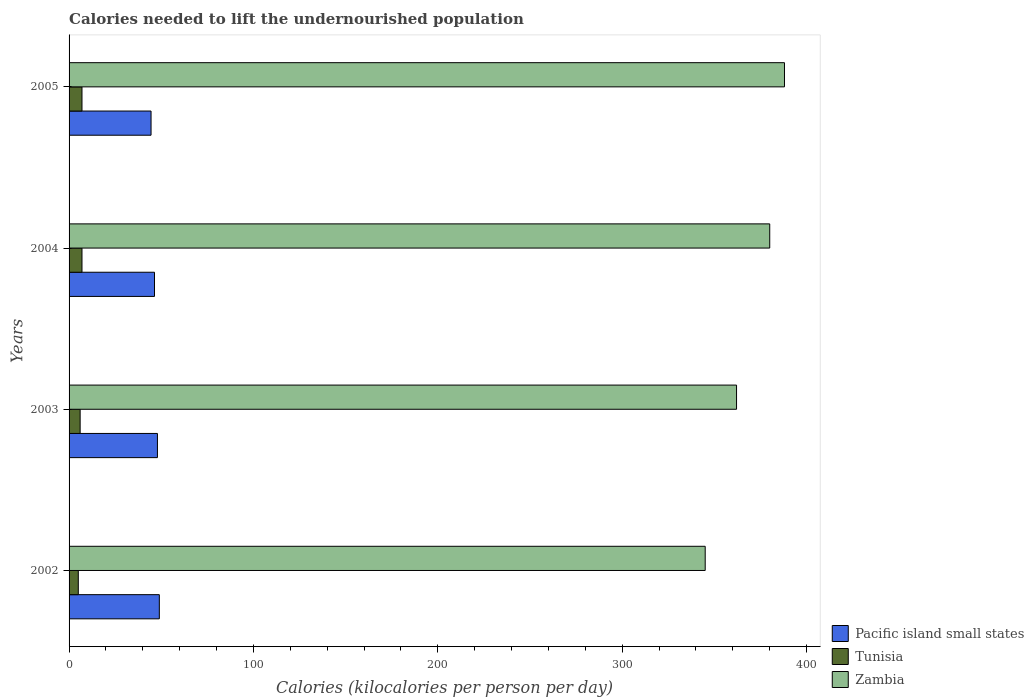How many different coloured bars are there?
Your answer should be very brief. 3. How many groups of bars are there?
Provide a succinct answer. 4. How many bars are there on the 4th tick from the top?
Offer a terse response. 3. How many bars are there on the 2nd tick from the bottom?
Your answer should be very brief. 3. What is the total calories needed to lift the undernourished population in Zambia in 2003?
Offer a very short reply. 362. Across all years, what is the maximum total calories needed to lift the undernourished population in Zambia?
Give a very brief answer. 388. Across all years, what is the minimum total calories needed to lift the undernourished population in Pacific island small states?
Provide a succinct answer. 44.46. What is the total total calories needed to lift the undernourished population in Pacific island small states in the graph?
Keep it short and to the point. 187.66. What is the difference between the total calories needed to lift the undernourished population in Tunisia in 2002 and that in 2005?
Your answer should be very brief. -2. What is the difference between the total calories needed to lift the undernourished population in Tunisia in 2005 and the total calories needed to lift the undernourished population in Pacific island small states in 2003?
Offer a very short reply. -40.92. What is the average total calories needed to lift the undernourished population in Tunisia per year?
Provide a succinct answer. 6.25. In the year 2002, what is the difference between the total calories needed to lift the undernourished population in Pacific island small states and total calories needed to lift the undernourished population in Zambia?
Provide a short and direct response. -296.05. What is the ratio of the total calories needed to lift the undernourished population in Zambia in 2002 to that in 2004?
Keep it short and to the point. 0.91. Is the total calories needed to lift the undernourished population in Zambia in 2002 less than that in 2004?
Provide a short and direct response. Yes. What is the difference between the highest and the lowest total calories needed to lift the undernourished population in Zambia?
Your answer should be compact. 43. Is the sum of the total calories needed to lift the undernourished population in Pacific island small states in 2003 and 2005 greater than the maximum total calories needed to lift the undernourished population in Zambia across all years?
Keep it short and to the point. No. What does the 2nd bar from the top in 2003 represents?
Keep it short and to the point. Tunisia. What does the 1st bar from the bottom in 2003 represents?
Give a very brief answer. Pacific island small states. Is it the case that in every year, the sum of the total calories needed to lift the undernourished population in Tunisia and total calories needed to lift the undernourished population in Zambia is greater than the total calories needed to lift the undernourished population in Pacific island small states?
Give a very brief answer. Yes. Are all the bars in the graph horizontal?
Offer a terse response. Yes. How many years are there in the graph?
Keep it short and to the point. 4. What is the difference between two consecutive major ticks on the X-axis?
Ensure brevity in your answer.  100. Are the values on the major ticks of X-axis written in scientific E-notation?
Your response must be concise. No. Does the graph contain any zero values?
Provide a succinct answer. No. How many legend labels are there?
Offer a terse response. 3. How are the legend labels stacked?
Your answer should be very brief. Vertical. What is the title of the graph?
Ensure brevity in your answer.  Calories needed to lift the undernourished population. What is the label or title of the X-axis?
Ensure brevity in your answer.  Calories (kilocalories per person per day). What is the Calories (kilocalories per person per day) of Pacific island small states in 2002?
Offer a very short reply. 48.95. What is the Calories (kilocalories per person per day) of Tunisia in 2002?
Offer a very short reply. 5. What is the Calories (kilocalories per person per day) in Zambia in 2002?
Offer a terse response. 345. What is the Calories (kilocalories per person per day) of Pacific island small states in 2003?
Your answer should be compact. 47.92. What is the Calories (kilocalories per person per day) of Tunisia in 2003?
Your answer should be compact. 6. What is the Calories (kilocalories per person per day) in Zambia in 2003?
Keep it short and to the point. 362. What is the Calories (kilocalories per person per day) in Pacific island small states in 2004?
Your answer should be compact. 46.33. What is the Calories (kilocalories per person per day) in Tunisia in 2004?
Offer a very short reply. 7. What is the Calories (kilocalories per person per day) of Zambia in 2004?
Offer a very short reply. 380. What is the Calories (kilocalories per person per day) in Pacific island small states in 2005?
Make the answer very short. 44.46. What is the Calories (kilocalories per person per day) of Zambia in 2005?
Keep it short and to the point. 388. Across all years, what is the maximum Calories (kilocalories per person per day) in Pacific island small states?
Your answer should be compact. 48.95. Across all years, what is the maximum Calories (kilocalories per person per day) of Zambia?
Keep it short and to the point. 388. Across all years, what is the minimum Calories (kilocalories per person per day) of Pacific island small states?
Make the answer very short. 44.46. Across all years, what is the minimum Calories (kilocalories per person per day) of Tunisia?
Give a very brief answer. 5. Across all years, what is the minimum Calories (kilocalories per person per day) in Zambia?
Make the answer very short. 345. What is the total Calories (kilocalories per person per day) in Pacific island small states in the graph?
Your answer should be very brief. 187.66. What is the total Calories (kilocalories per person per day) of Zambia in the graph?
Your response must be concise. 1475. What is the difference between the Calories (kilocalories per person per day) in Pacific island small states in 2002 and that in 2003?
Your answer should be compact. 1.03. What is the difference between the Calories (kilocalories per person per day) in Tunisia in 2002 and that in 2003?
Offer a terse response. -1. What is the difference between the Calories (kilocalories per person per day) in Pacific island small states in 2002 and that in 2004?
Ensure brevity in your answer.  2.62. What is the difference between the Calories (kilocalories per person per day) in Tunisia in 2002 and that in 2004?
Your answer should be compact. -2. What is the difference between the Calories (kilocalories per person per day) of Zambia in 2002 and that in 2004?
Provide a short and direct response. -35. What is the difference between the Calories (kilocalories per person per day) of Pacific island small states in 2002 and that in 2005?
Provide a succinct answer. 4.49. What is the difference between the Calories (kilocalories per person per day) of Zambia in 2002 and that in 2005?
Keep it short and to the point. -43. What is the difference between the Calories (kilocalories per person per day) of Pacific island small states in 2003 and that in 2004?
Provide a short and direct response. 1.59. What is the difference between the Calories (kilocalories per person per day) in Tunisia in 2003 and that in 2004?
Provide a succinct answer. -1. What is the difference between the Calories (kilocalories per person per day) of Pacific island small states in 2003 and that in 2005?
Offer a terse response. 3.47. What is the difference between the Calories (kilocalories per person per day) of Tunisia in 2003 and that in 2005?
Make the answer very short. -1. What is the difference between the Calories (kilocalories per person per day) in Zambia in 2003 and that in 2005?
Your answer should be very brief. -26. What is the difference between the Calories (kilocalories per person per day) in Pacific island small states in 2004 and that in 2005?
Keep it short and to the point. 1.87. What is the difference between the Calories (kilocalories per person per day) of Zambia in 2004 and that in 2005?
Provide a short and direct response. -8. What is the difference between the Calories (kilocalories per person per day) in Pacific island small states in 2002 and the Calories (kilocalories per person per day) in Tunisia in 2003?
Provide a short and direct response. 42.95. What is the difference between the Calories (kilocalories per person per day) in Pacific island small states in 2002 and the Calories (kilocalories per person per day) in Zambia in 2003?
Offer a terse response. -313.05. What is the difference between the Calories (kilocalories per person per day) in Tunisia in 2002 and the Calories (kilocalories per person per day) in Zambia in 2003?
Your answer should be compact. -357. What is the difference between the Calories (kilocalories per person per day) of Pacific island small states in 2002 and the Calories (kilocalories per person per day) of Tunisia in 2004?
Your answer should be compact. 41.95. What is the difference between the Calories (kilocalories per person per day) of Pacific island small states in 2002 and the Calories (kilocalories per person per day) of Zambia in 2004?
Provide a succinct answer. -331.05. What is the difference between the Calories (kilocalories per person per day) in Tunisia in 2002 and the Calories (kilocalories per person per day) in Zambia in 2004?
Your response must be concise. -375. What is the difference between the Calories (kilocalories per person per day) of Pacific island small states in 2002 and the Calories (kilocalories per person per day) of Tunisia in 2005?
Your answer should be compact. 41.95. What is the difference between the Calories (kilocalories per person per day) of Pacific island small states in 2002 and the Calories (kilocalories per person per day) of Zambia in 2005?
Ensure brevity in your answer.  -339.05. What is the difference between the Calories (kilocalories per person per day) of Tunisia in 2002 and the Calories (kilocalories per person per day) of Zambia in 2005?
Your answer should be very brief. -383. What is the difference between the Calories (kilocalories per person per day) of Pacific island small states in 2003 and the Calories (kilocalories per person per day) of Tunisia in 2004?
Keep it short and to the point. 40.92. What is the difference between the Calories (kilocalories per person per day) of Pacific island small states in 2003 and the Calories (kilocalories per person per day) of Zambia in 2004?
Make the answer very short. -332.08. What is the difference between the Calories (kilocalories per person per day) in Tunisia in 2003 and the Calories (kilocalories per person per day) in Zambia in 2004?
Provide a succinct answer. -374. What is the difference between the Calories (kilocalories per person per day) in Pacific island small states in 2003 and the Calories (kilocalories per person per day) in Tunisia in 2005?
Provide a short and direct response. 40.92. What is the difference between the Calories (kilocalories per person per day) in Pacific island small states in 2003 and the Calories (kilocalories per person per day) in Zambia in 2005?
Provide a short and direct response. -340.08. What is the difference between the Calories (kilocalories per person per day) of Tunisia in 2003 and the Calories (kilocalories per person per day) of Zambia in 2005?
Your answer should be very brief. -382. What is the difference between the Calories (kilocalories per person per day) in Pacific island small states in 2004 and the Calories (kilocalories per person per day) in Tunisia in 2005?
Keep it short and to the point. 39.33. What is the difference between the Calories (kilocalories per person per day) of Pacific island small states in 2004 and the Calories (kilocalories per person per day) of Zambia in 2005?
Give a very brief answer. -341.67. What is the difference between the Calories (kilocalories per person per day) in Tunisia in 2004 and the Calories (kilocalories per person per day) in Zambia in 2005?
Provide a short and direct response. -381. What is the average Calories (kilocalories per person per day) of Pacific island small states per year?
Your response must be concise. 46.92. What is the average Calories (kilocalories per person per day) of Tunisia per year?
Offer a terse response. 6.25. What is the average Calories (kilocalories per person per day) in Zambia per year?
Give a very brief answer. 368.75. In the year 2002, what is the difference between the Calories (kilocalories per person per day) in Pacific island small states and Calories (kilocalories per person per day) in Tunisia?
Provide a short and direct response. 43.95. In the year 2002, what is the difference between the Calories (kilocalories per person per day) of Pacific island small states and Calories (kilocalories per person per day) of Zambia?
Provide a succinct answer. -296.05. In the year 2002, what is the difference between the Calories (kilocalories per person per day) of Tunisia and Calories (kilocalories per person per day) of Zambia?
Offer a terse response. -340. In the year 2003, what is the difference between the Calories (kilocalories per person per day) in Pacific island small states and Calories (kilocalories per person per day) in Tunisia?
Give a very brief answer. 41.92. In the year 2003, what is the difference between the Calories (kilocalories per person per day) in Pacific island small states and Calories (kilocalories per person per day) in Zambia?
Make the answer very short. -314.08. In the year 2003, what is the difference between the Calories (kilocalories per person per day) in Tunisia and Calories (kilocalories per person per day) in Zambia?
Ensure brevity in your answer.  -356. In the year 2004, what is the difference between the Calories (kilocalories per person per day) in Pacific island small states and Calories (kilocalories per person per day) in Tunisia?
Give a very brief answer. 39.33. In the year 2004, what is the difference between the Calories (kilocalories per person per day) in Pacific island small states and Calories (kilocalories per person per day) in Zambia?
Ensure brevity in your answer.  -333.67. In the year 2004, what is the difference between the Calories (kilocalories per person per day) in Tunisia and Calories (kilocalories per person per day) in Zambia?
Ensure brevity in your answer.  -373. In the year 2005, what is the difference between the Calories (kilocalories per person per day) in Pacific island small states and Calories (kilocalories per person per day) in Tunisia?
Give a very brief answer. 37.46. In the year 2005, what is the difference between the Calories (kilocalories per person per day) of Pacific island small states and Calories (kilocalories per person per day) of Zambia?
Provide a succinct answer. -343.54. In the year 2005, what is the difference between the Calories (kilocalories per person per day) in Tunisia and Calories (kilocalories per person per day) in Zambia?
Your answer should be very brief. -381. What is the ratio of the Calories (kilocalories per person per day) of Pacific island small states in 2002 to that in 2003?
Offer a very short reply. 1.02. What is the ratio of the Calories (kilocalories per person per day) in Zambia in 2002 to that in 2003?
Make the answer very short. 0.95. What is the ratio of the Calories (kilocalories per person per day) in Pacific island small states in 2002 to that in 2004?
Make the answer very short. 1.06. What is the ratio of the Calories (kilocalories per person per day) in Zambia in 2002 to that in 2004?
Your response must be concise. 0.91. What is the ratio of the Calories (kilocalories per person per day) in Pacific island small states in 2002 to that in 2005?
Give a very brief answer. 1.1. What is the ratio of the Calories (kilocalories per person per day) in Zambia in 2002 to that in 2005?
Offer a terse response. 0.89. What is the ratio of the Calories (kilocalories per person per day) of Pacific island small states in 2003 to that in 2004?
Offer a very short reply. 1.03. What is the ratio of the Calories (kilocalories per person per day) in Tunisia in 2003 to that in 2004?
Offer a terse response. 0.86. What is the ratio of the Calories (kilocalories per person per day) of Zambia in 2003 to that in 2004?
Your response must be concise. 0.95. What is the ratio of the Calories (kilocalories per person per day) of Pacific island small states in 2003 to that in 2005?
Provide a short and direct response. 1.08. What is the ratio of the Calories (kilocalories per person per day) of Zambia in 2003 to that in 2005?
Your response must be concise. 0.93. What is the ratio of the Calories (kilocalories per person per day) in Pacific island small states in 2004 to that in 2005?
Your response must be concise. 1.04. What is the ratio of the Calories (kilocalories per person per day) of Tunisia in 2004 to that in 2005?
Offer a terse response. 1. What is the ratio of the Calories (kilocalories per person per day) in Zambia in 2004 to that in 2005?
Keep it short and to the point. 0.98. What is the difference between the highest and the second highest Calories (kilocalories per person per day) of Pacific island small states?
Offer a very short reply. 1.03. What is the difference between the highest and the lowest Calories (kilocalories per person per day) in Pacific island small states?
Your response must be concise. 4.49. What is the difference between the highest and the lowest Calories (kilocalories per person per day) of Zambia?
Your answer should be very brief. 43. 